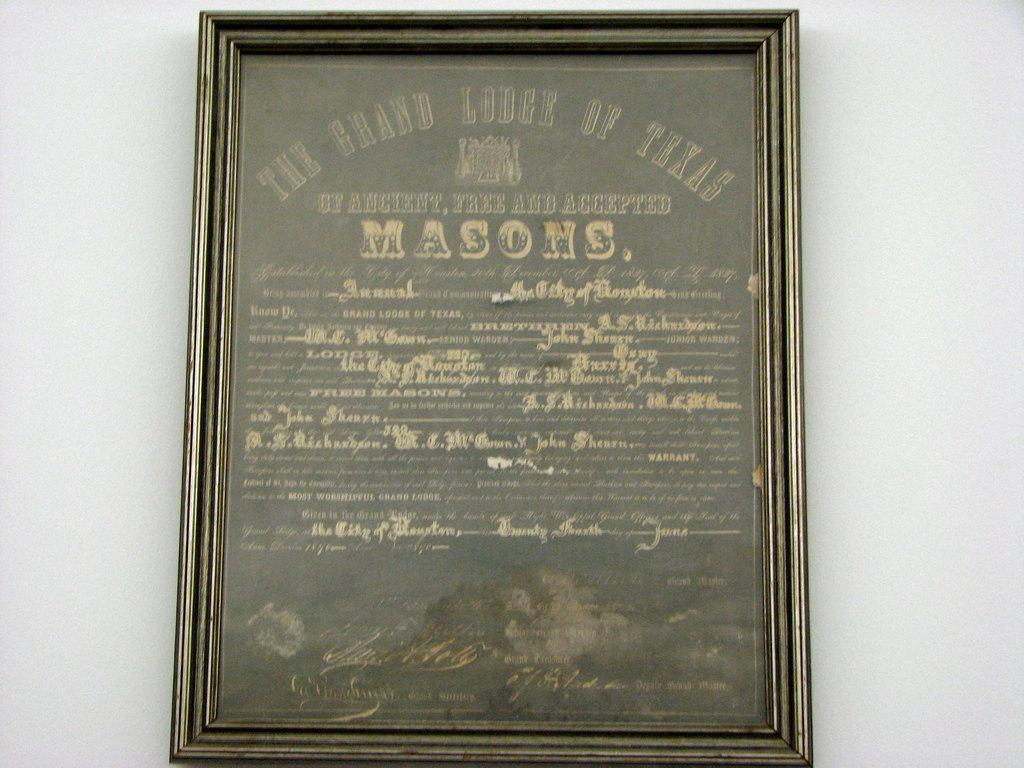What is the main subject in the image? There is a frame in the image. What is written or depicted on the frame? There is some text on the frame. What is the color of the background in the image? The background of the image is white. Can you see the band playing their instruments in the image? There is no band present in the image. How many wings can be seen on the frame in the image? The frame does not have any wings. 